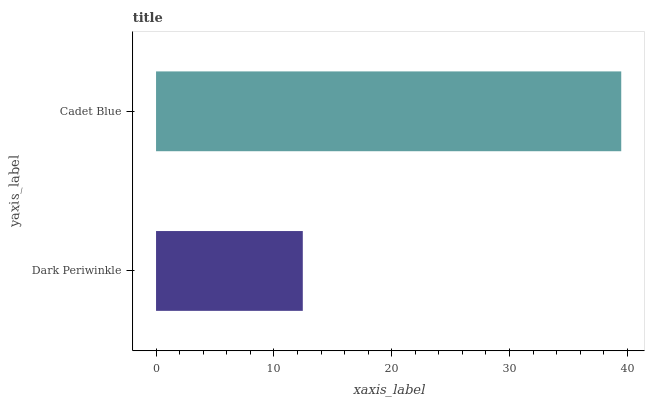Is Dark Periwinkle the minimum?
Answer yes or no. Yes. Is Cadet Blue the maximum?
Answer yes or no. Yes. Is Cadet Blue the minimum?
Answer yes or no. No. Is Cadet Blue greater than Dark Periwinkle?
Answer yes or no. Yes. Is Dark Periwinkle less than Cadet Blue?
Answer yes or no. Yes. Is Dark Periwinkle greater than Cadet Blue?
Answer yes or no. No. Is Cadet Blue less than Dark Periwinkle?
Answer yes or no. No. Is Cadet Blue the high median?
Answer yes or no. Yes. Is Dark Periwinkle the low median?
Answer yes or no. Yes. Is Dark Periwinkle the high median?
Answer yes or no. No. Is Cadet Blue the low median?
Answer yes or no. No. 